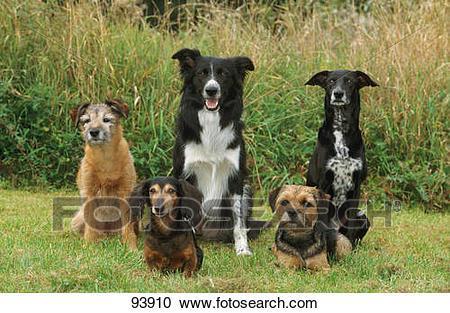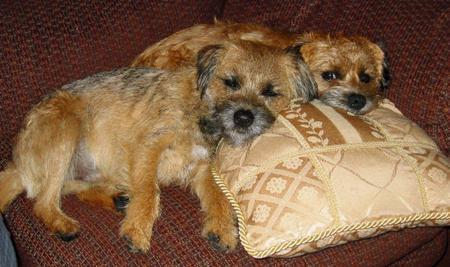The first image is the image on the left, the second image is the image on the right. Analyze the images presented: Is the assertion "In one of the images there are two dogs resting their heads on a pillow." valid? Answer yes or no. Yes. The first image is the image on the left, the second image is the image on the right. Analyze the images presented: Is the assertion "An image shows two dogs resting together with something pillow-like." valid? Answer yes or no. Yes. 